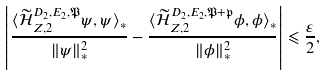<formula> <loc_0><loc_0><loc_500><loc_500>\left | \frac { \langle \widetilde { \mathcal { H } } _ { Z , 2 } ^ { D _ { 2 } , E _ { 2 } , \mathfrak { P } } \psi , \psi \rangle _ { * } } { \| \psi \| _ { * } ^ { 2 } } - \frac { \langle \widetilde { \mathcal { H } } _ { Z , 2 } ^ { D _ { 2 } , E _ { 2 } , \mathfrak { P } + \mathfrak { p } } \phi , \phi \rangle _ { * } } { \| \phi \| _ { * } ^ { 2 } } \right | \leqslant \frac { \varepsilon } { 2 } ,</formula> 